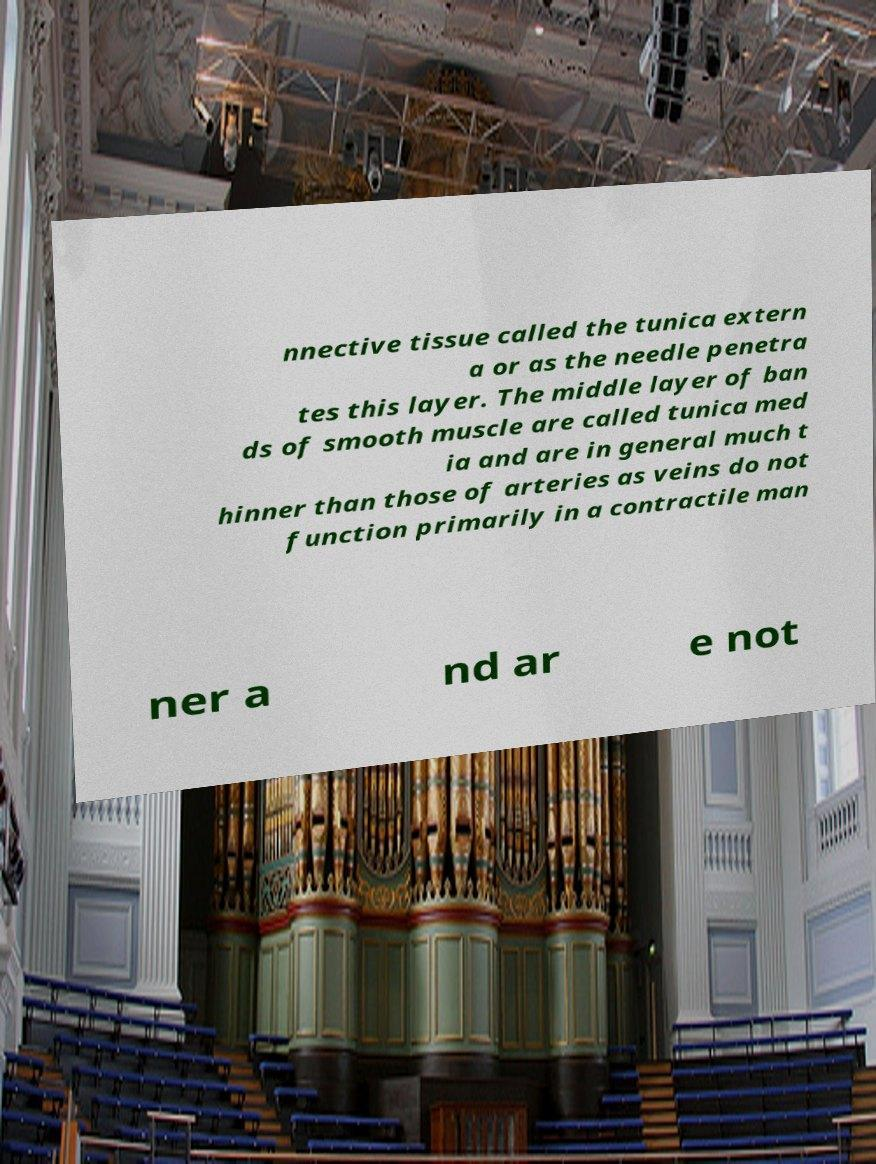Please identify and transcribe the text found in this image. nnective tissue called the tunica extern a or as the needle penetra tes this layer. The middle layer of ban ds of smooth muscle are called tunica med ia and are in general much t hinner than those of arteries as veins do not function primarily in a contractile man ner a nd ar e not 